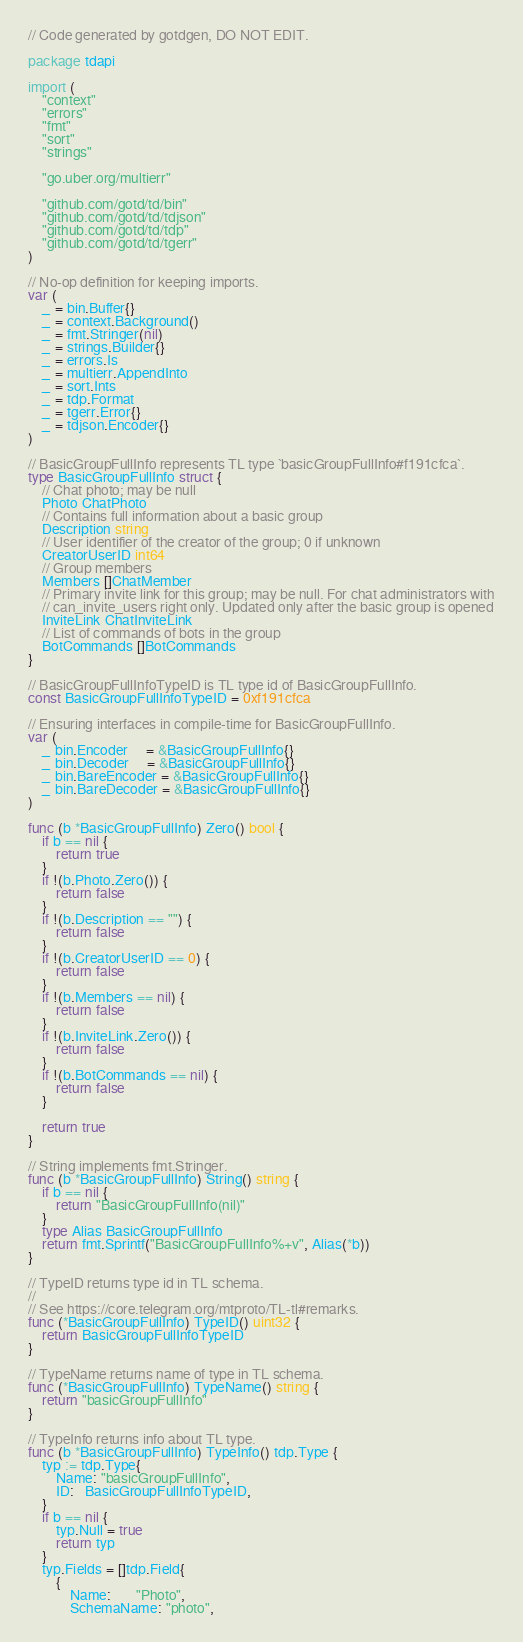<code> <loc_0><loc_0><loc_500><loc_500><_Go_>// Code generated by gotdgen, DO NOT EDIT.

package tdapi

import (
	"context"
	"errors"
	"fmt"
	"sort"
	"strings"

	"go.uber.org/multierr"

	"github.com/gotd/td/bin"
	"github.com/gotd/td/tdjson"
	"github.com/gotd/td/tdp"
	"github.com/gotd/td/tgerr"
)

// No-op definition for keeping imports.
var (
	_ = bin.Buffer{}
	_ = context.Background()
	_ = fmt.Stringer(nil)
	_ = strings.Builder{}
	_ = errors.Is
	_ = multierr.AppendInto
	_ = sort.Ints
	_ = tdp.Format
	_ = tgerr.Error{}
	_ = tdjson.Encoder{}
)

// BasicGroupFullInfo represents TL type `basicGroupFullInfo#f191cfca`.
type BasicGroupFullInfo struct {
	// Chat photo; may be null
	Photo ChatPhoto
	// Contains full information about a basic group
	Description string
	// User identifier of the creator of the group; 0 if unknown
	CreatorUserID int64
	// Group members
	Members []ChatMember
	// Primary invite link for this group; may be null. For chat administrators with
	// can_invite_users right only. Updated only after the basic group is opened
	InviteLink ChatInviteLink
	// List of commands of bots in the group
	BotCommands []BotCommands
}

// BasicGroupFullInfoTypeID is TL type id of BasicGroupFullInfo.
const BasicGroupFullInfoTypeID = 0xf191cfca

// Ensuring interfaces in compile-time for BasicGroupFullInfo.
var (
	_ bin.Encoder     = &BasicGroupFullInfo{}
	_ bin.Decoder     = &BasicGroupFullInfo{}
	_ bin.BareEncoder = &BasicGroupFullInfo{}
	_ bin.BareDecoder = &BasicGroupFullInfo{}
)

func (b *BasicGroupFullInfo) Zero() bool {
	if b == nil {
		return true
	}
	if !(b.Photo.Zero()) {
		return false
	}
	if !(b.Description == "") {
		return false
	}
	if !(b.CreatorUserID == 0) {
		return false
	}
	if !(b.Members == nil) {
		return false
	}
	if !(b.InviteLink.Zero()) {
		return false
	}
	if !(b.BotCommands == nil) {
		return false
	}

	return true
}

// String implements fmt.Stringer.
func (b *BasicGroupFullInfo) String() string {
	if b == nil {
		return "BasicGroupFullInfo(nil)"
	}
	type Alias BasicGroupFullInfo
	return fmt.Sprintf("BasicGroupFullInfo%+v", Alias(*b))
}

// TypeID returns type id in TL schema.
//
// See https://core.telegram.org/mtproto/TL-tl#remarks.
func (*BasicGroupFullInfo) TypeID() uint32 {
	return BasicGroupFullInfoTypeID
}

// TypeName returns name of type in TL schema.
func (*BasicGroupFullInfo) TypeName() string {
	return "basicGroupFullInfo"
}

// TypeInfo returns info about TL type.
func (b *BasicGroupFullInfo) TypeInfo() tdp.Type {
	typ := tdp.Type{
		Name: "basicGroupFullInfo",
		ID:   BasicGroupFullInfoTypeID,
	}
	if b == nil {
		typ.Null = true
		return typ
	}
	typ.Fields = []tdp.Field{
		{
			Name:       "Photo",
			SchemaName: "photo",</code> 